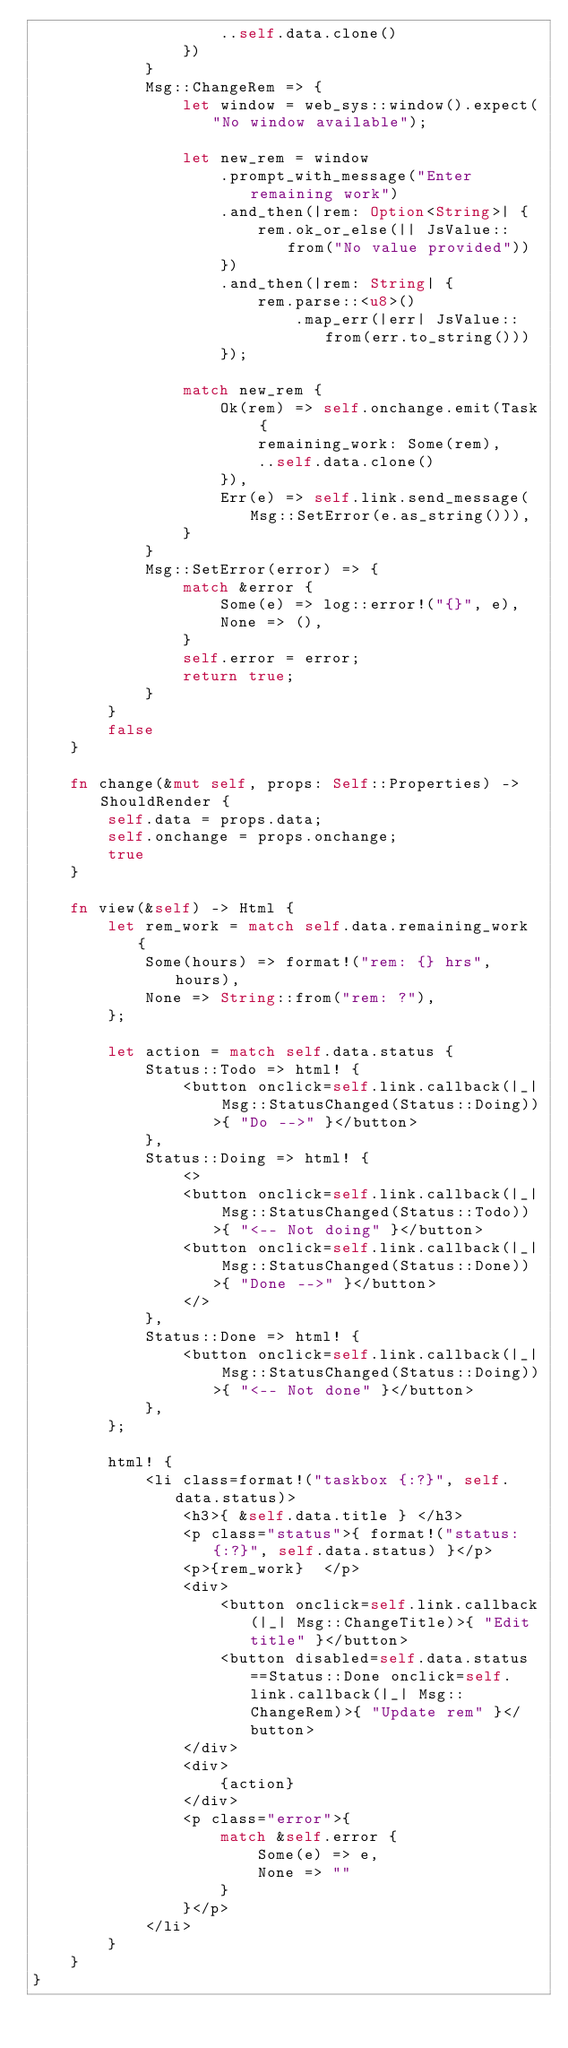<code> <loc_0><loc_0><loc_500><loc_500><_Rust_>                    ..self.data.clone()
                })
            }
            Msg::ChangeRem => {
                let window = web_sys::window().expect("No window available");

                let new_rem = window
                    .prompt_with_message("Enter remaining work")
                    .and_then(|rem: Option<String>| {
                        rem.ok_or_else(|| JsValue::from("No value provided"))
                    })
                    .and_then(|rem: String| {
                        rem.parse::<u8>()
                            .map_err(|err| JsValue::from(err.to_string()))
                    });

                match new_rem {
                    Ok(rem) => self.onchange.emit(Task {
                        remaining_work: Some(rem),
                        ..self.data.clone()
                    }),
                    Err(e) => self.link.send_message(Msg::SetError(e.as_string())),
                }
            }
            Msg::SetError(error) => {
                match &error {
                    Some(e) => log::error!("{}", e),
                    None => (),
                }
                self.error = error;
                return true;
            }
        }
        false
    }

    fn change(&mut self, props: Self::Properties) -> ShouldRender {
        self.data = props.data;
        self.onchange = props.onchange;
        true
    }

    fn view(&self) -> Html {
        let rem_work = match self.data.remaining_work {
            Some(hours) => format!("rem: {} hrs", hours),
            None => String::from("rem: ?"),
        };

        let action = match self.data.status {
            Status::Todo => html! {
                <button onclick=self.link.callback(|_| Msg::StatusChanged(Status::Doing))>{ "Do -->" }</button>
            },
            Status::Doing => html! {
                <>
                <button onclick=self.link.callback(|_| Msg::StatusChanged(Status::Todo))>{ "<-- Not doing" }</button>
                <button onclick=self.link.callback(|_| Msg::StatusChanged(Status::Done))>{ "Done -->" }</button>
                </>
            },
            Status::Done => html! {
                <button onclick=self.link.callback(|_| Msg::StatusChanged(Status::Doing))>{ "<-- Not done" }</button>
            },
        };

        html! {
            <li class=format!("taskbox {:?}", self.data.status)>
                <h3>{ &self.data.title } </h3>
                <p class="status">{ format!("status: {:?}", self.data.status) }</p>
                <p>{rem_work}  </p>
                <div>
                    <button onclick=self.link.callback(|_| Msg::ChangeTitle)>{ "Edit title" }</button>
                    <button disabled=self.data.status==Status::Done onclick=self.link.callback(|_| Msg::ChangeRem)>{ "Update rem" }</button>
                </div>
                <div>
                    {action}
                </div>
                <p class="error">{
                    match &self.error {
                        Some(e) => e,
                        None => ""
                    }
                }</p>
            </li>
        }
    }
}
</code> 